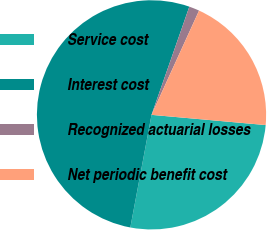<chart> <loc_0><loc_0><loc_500><loc_500><pie_chart><fcel>Service cost<fcel>Interest cost<fcel>Recognized actuarial losses<fcel>Net periodic benefit cost<nl><fcel>26.54%<fcel>52.39%<fcel>1.46%<fcel>19.61%<nl></chart> 